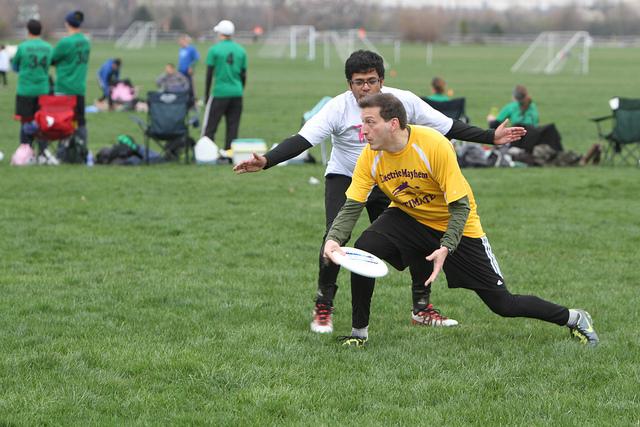What are these boys playing?
Quick response, please. Frisbee. What kind of nuts are in the background?
Short answer required. Soccer. Are these two men in danger of running into one another?
Concise answer only. No. Is the man in front wearing cleats?
Be succinct. Yes. How many people are in the picture?
Keep it brief. 11. Does the man in the white shirt look aggressive?
Short answer required. No. What is the man wearing over his pants?
Write a very short answer. Shorts. How many people are on the sideline?
Quick response, please. 5. What game is being played?
Short answer required. Frisbee. What is the man holding?
Answer briefly. Frisbee. What sport is being played?
Keep it brief. Frisbee. How old are the boys?
Answer briefly. 20's. 